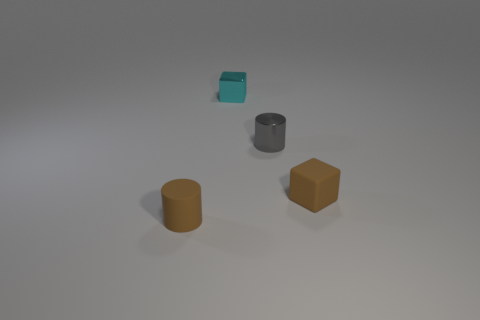Do the rubber block and the rubber cylinder have the same color? Yes, upon inspecting the image, the rubber block and the cylinder appear to share a consistent shade of grey, indicating they are of the same color. 